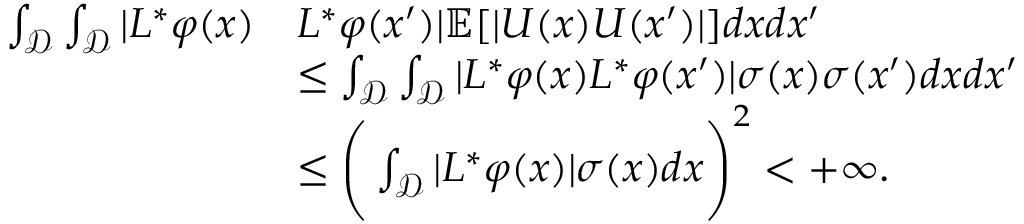<formula> <loc_0><loc_0><loc_500><loc_500>\begin{array} { r l } { \int _ { \mathcal { D } } \int _ { \mathcal { D } } | L ^ { * } \varphi ( x ) } & { L ^ { * } \varphi ( x ^ { \prime } ) | \mathbb { E } [ | U ( x ) U ( x ^ { \prime } ) | ] d x d x ^ { \prime } } \\ & { \leq \int _ { \mathcal { D } } \int _ { \mathcal { D } } | L ^ { * } \varphi ( x ) L ^ { * } \varphi ( x ^ { \prime } ) | \sigma ( x ) \sigma ( x ^ { \prime } ) d x d x ^ { \prime } } \\ & { \leq \left ( \int _ { \mathcal { D } } | L ^ { * } \varphi ( x ) | \sigma ( x ) d x \right ) ^ { 2 } < + \infty . } \end{array}</formula> 